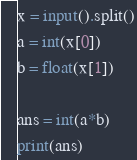Convert code to text. <code><loc_0><loc_0><loc_500><loc_500><_Python_>x = input().split()
a = int(x[0])
b = float(x[1])

ans = int(a*b)
print(ans)</code> 